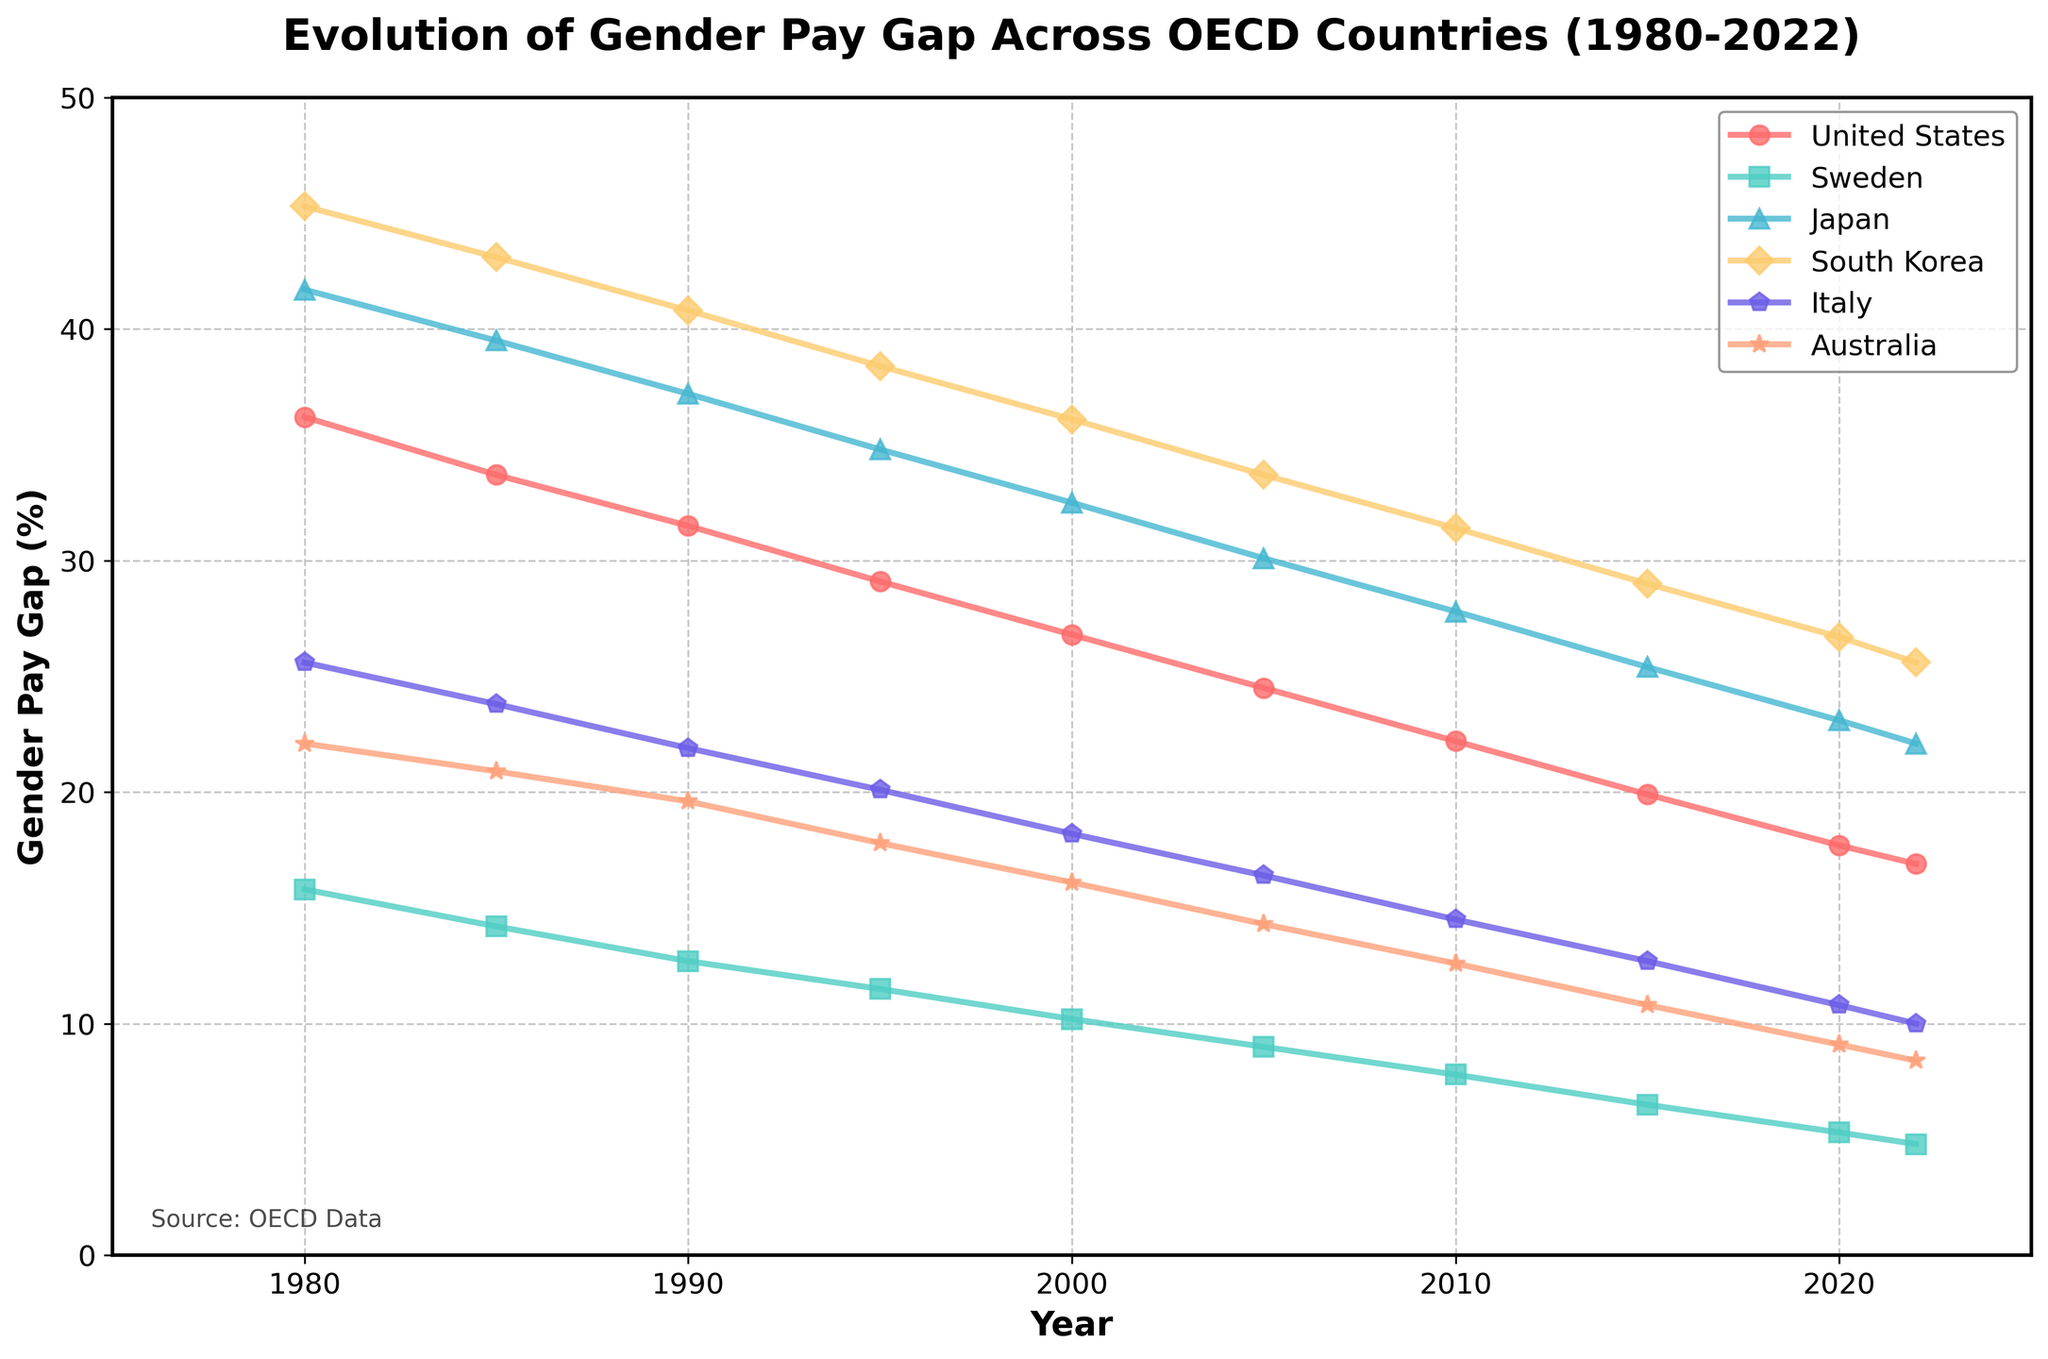Which country showed the greatest reduction in the gender pay gap from 1980 to 2022? First, look at the data points for each country in 1980 and 2022. Calculate the reduction for each country by subtracting the 2022 value from the 1980 value. The country with the largest difference is the one with the greatest reduction. For the United States, the reduction is 36.2 - 16.9 = 19.3 percentage points; for Sweden, it's 15.8 - 4.8 = 11.0 percentage points; for Japan, it's 41.7 - 22.1 = 19.6 percentage points; for South Korea, it's 45.3 - 25.6 = 19.7 percentage points; for Italy, it's 25.6 - 10.0 = 15.6 percentage points; and for Australia, it's 22.1 - 8.4 = 13.7 percentage points. South Korea has the greatest reduction.
Answer: South Korea How did the gender pay gap in the United States change between 2010 and 2022? Check the data points for the United States in 2010 and 2022. The gender pay gap in the United States in 2010 was 22.2%, and in 2022 it was 16.9%. Calculate the change by subtracting the 2022 value from the 2010 value: 22.2 - 16.9 = 5.3 percentage points.
Answer: Decreased by 5.3 percentage points Which country had the smallest gender pay gap in 2022? Look at the data points for all countries in 2022. Find the smallest value among these data points. The smallest value is 4.8% for Sweden.
Answer: Sweden What is the average gender pay gap in 2000 across all listed countries? Look at the data points for each country in 2000. Sum the values: 26.8 (United States) + 10.2 (Sweden) + 32.5 (Japan) + 36.1 (South Korea) + 18.2 (Italy) + 16.1 (Australia) = 139.9. Then divide by the number of countries (6): 139.9 / 6 ≈ 23.32%.
Answer: 23.32% Which country consistently had the highest gender pay gap from 1980 to 2022? By looking at each time point (year) and identifying the highest value for each, Japan and South Korea are contenders. Repeatedly, South Korea has either the highest or second highest values until the end. Confirm by closely examining the trends, South Korea consistently shows the highest or one of the highest values, narrowly winning over Japan.
Answer: South Korea How many countries had a gender pay gap less than 15% in 2022? Look at the data for 2022. Count the number of countries where the value is less than 15%. Sweden (4.8%), Italy (10.0%), and Australia (8.4%) show less than 15%.
Answer: 3 countries Comparing Italy and Sweden, which country showed a more significant decrease in the gender pay gap from 1980 to 2022? Calculate the decrease for both Italy and Sweden. For Italy, it's 25.6 - 10.0 = 15.6 percentage points. For Sweden, it's 15.8 - 4.8 = 11.0 percentage points. Compare the two values. Italy's decrease is more significant.
Answer: Italy What is the visual difference in the trend line for Japan and Australia from 1980 to 2022? Look at the trend lines for Japan and Australia. Calculate the overall change from 1980 to 2022 for both countries. Japan decreases from 41.7 to 22.1 (19.6 percentage points), and Australia from 22.1 to 8.4 (13.7 percentage points). Japan shows a steeper decline and had a higher initial and final value compared to Australia.
Answer: Japan has a steeper decline How many countries had a gender pay gap reduction of more than 15 percentage points from 1980 to 2022? Calculate the reduction for each country individually. From previous calculations, the reductions are: United States (19.3), Sweden (11.0), Japan (19.6), South Korea (19.7), Italy (15.6), and Australia (13.7). Count countries with reductions greater than 15 points: United States, Japan, South Korea, and Italy.
Answer: 4 countries 